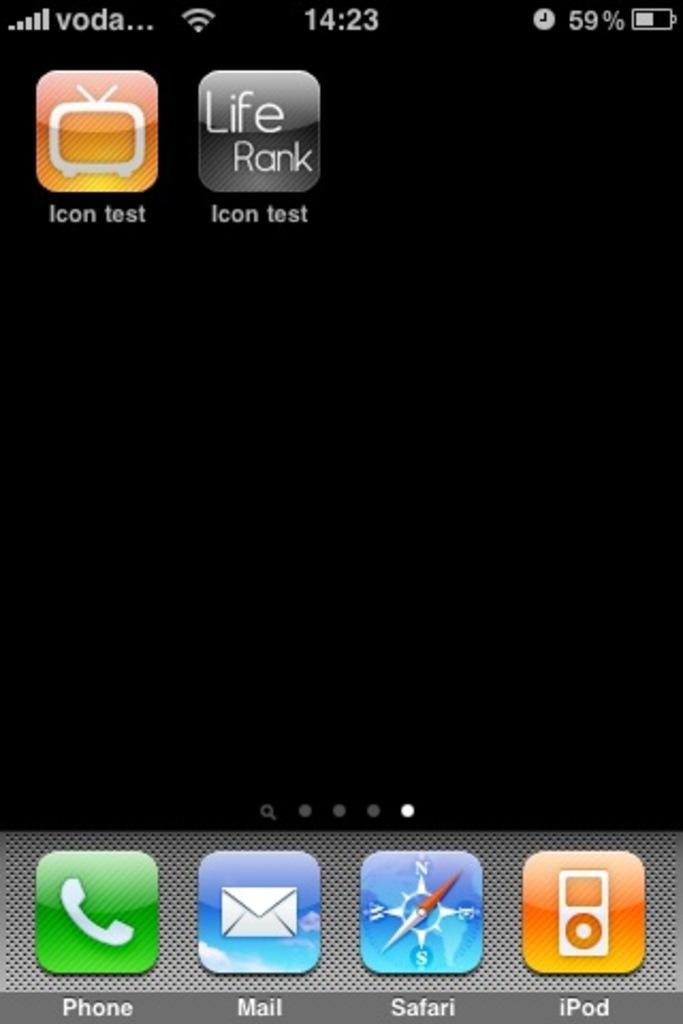<image>
Render a clear and concise summary of the photo. A smartphone screen with the Safari and iPod app at the bottom. 